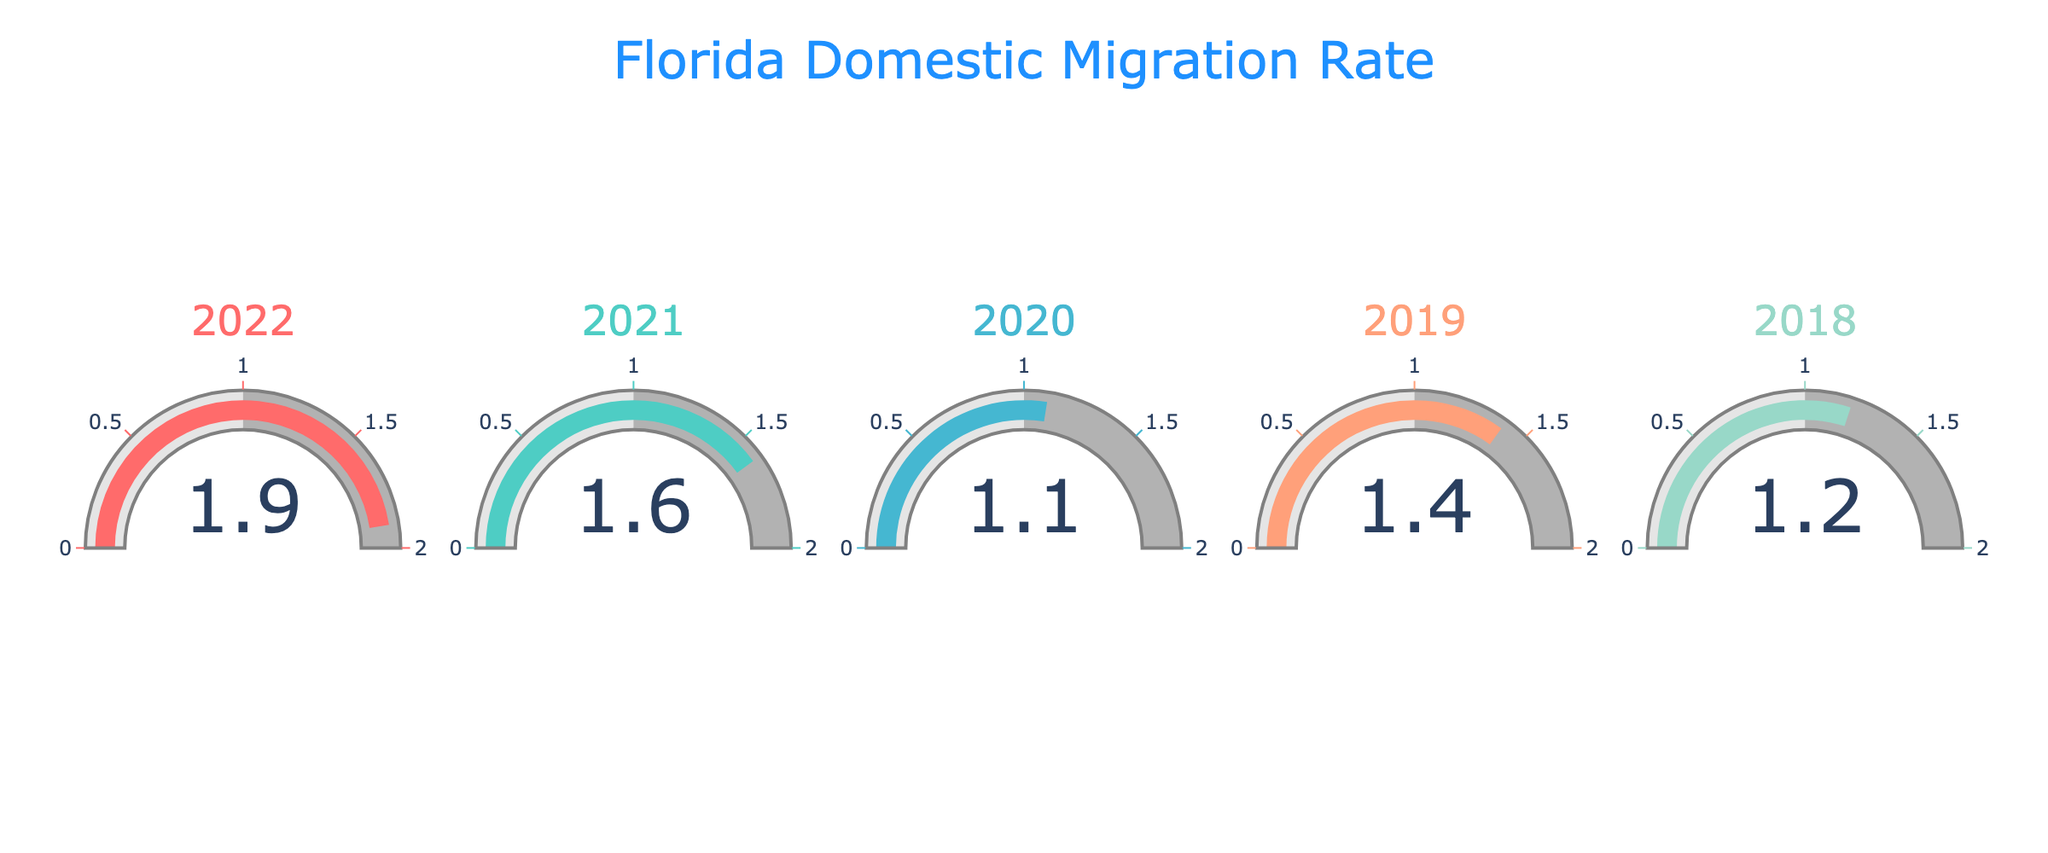What value is shown for the year 2022? The gauge for the year 2022 indicates a value of 1.9.
Answer: 1.9 Which year shows the lowest domestic migration rate? Comparing all the gauges, the year with the lowest displayed value is 2020, which shows a value of 1.1.
Answer: 2020 What is the average migration rate from 2018 to 2022? Adding the rates from 2018 (1.2), 2019 (1.4), 2020 (1.1), 2021 (1.6), and 2022 (1.9) gives 7.2. Dividing by 5 gives an average of 1.44.
Answer: 1.44 How much did the migration rate increase from 2020 to 2022? Subtract the migration rate in 2020 (1.1) from the migration rate in 2022 (1.9). 1.9 - 1.1 = 0.8.
Answer: 0.8 Which year had a higher migration rate, 2019 or 2021? Comparing the values for 2019 (1.4) and 2021 (1.6), the year 2021 had a higher migration rate.
Answer: 2021 How many gauges display a migration rate above 1.5? The gauges for 2021 (1.6) and 2022 (1.9) show values above 1.5. So, there are 2 gauges.
Answer: 2 Which year displayed a migration rate that is closest to the average migration rate from 2018 to 2022? The average is 1.44. The closest value among the gauges is 2019 (1.4), as it is nearest to 1.44.
Answer: 2019 What is the total migration rate for all years combined? Summing up the migration rates: 1.2 (2018) + 1.4 (2019) + 1.1 (2020) + 1.6 (2021) + 1.9 (2022) = 7.2.
Answer: 7.2 Was there any year with a migration rate exactly equal to 1.5? None of the displayed values on the gauges equal exactly 1.5.
Answer: No 